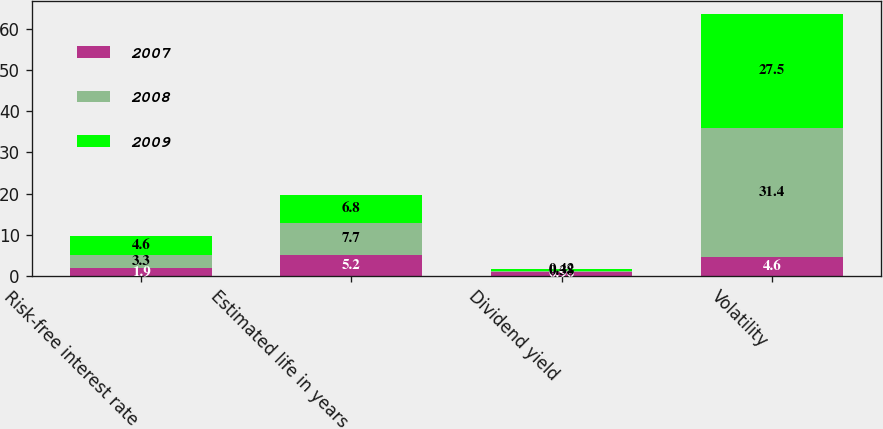<chart> <loc_0><loc_0><loc_500><loc_500><stacked_bar_chart><ecel><fcel>Risk-free interest rate<fcel>Estimated life in years<fcel>Dividend yield<fcel>Volatility<nl><fcel>2007<fcel>1.9<fcel>5.2<fcel>0.96<fcel>4.6<nl><fcel>2008<fcel>3.3<fcel>7.7<fcel>0.38<fcel>31.4<nl><fcel>2009<fcel>4.6<fcel>6.8<fcel>0.42<fcel>27.5<nl></chart> 